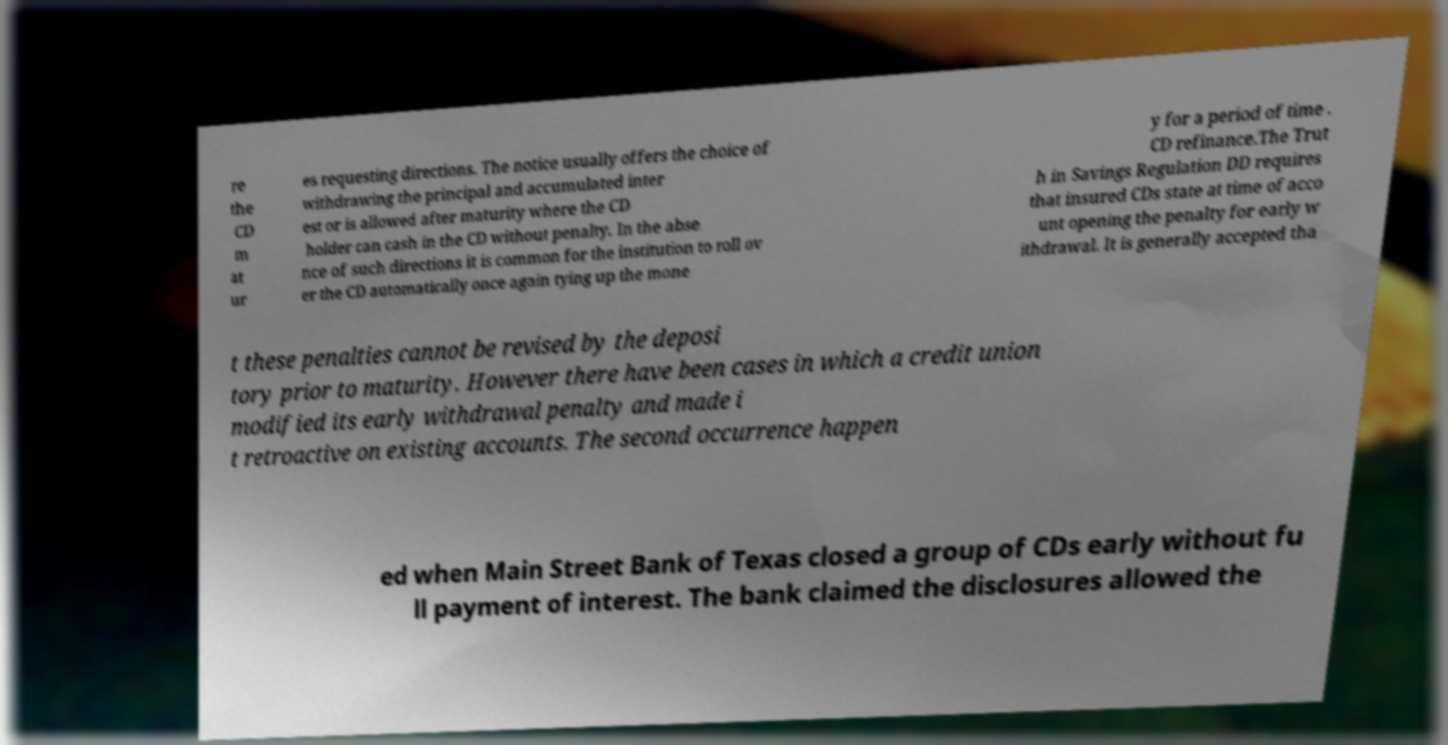Please read and relay the text visible in this image. What does it say? re the CD m at ur es requesting directions. The notice usually offers the choice of withdrawing the principal and accumulated inter est or is allowed after maturity where the CD holder can cash in the CD without penalty. In the abse nce of such directions it is common for the institution to roll ov er the CD automatically once again tying up the mone y for a period of time . CD refinance.The Trut h in Savings Regulation DD requires that insured CDs state at time of acco unt opening the penalty for early w ithdrawal. It is generally accepted tha t these penalties cannot be revised by the deposi tory prior to maturity. However there have been cases in which a credit union modified its early withdrawal penalty and made i t retroactive on existing accounts. The second occurrence happen ed when Main Street Bank of Texas closed a group of CDs early without fu ll payment of interest. The bank claimed the disclosures allowed the 